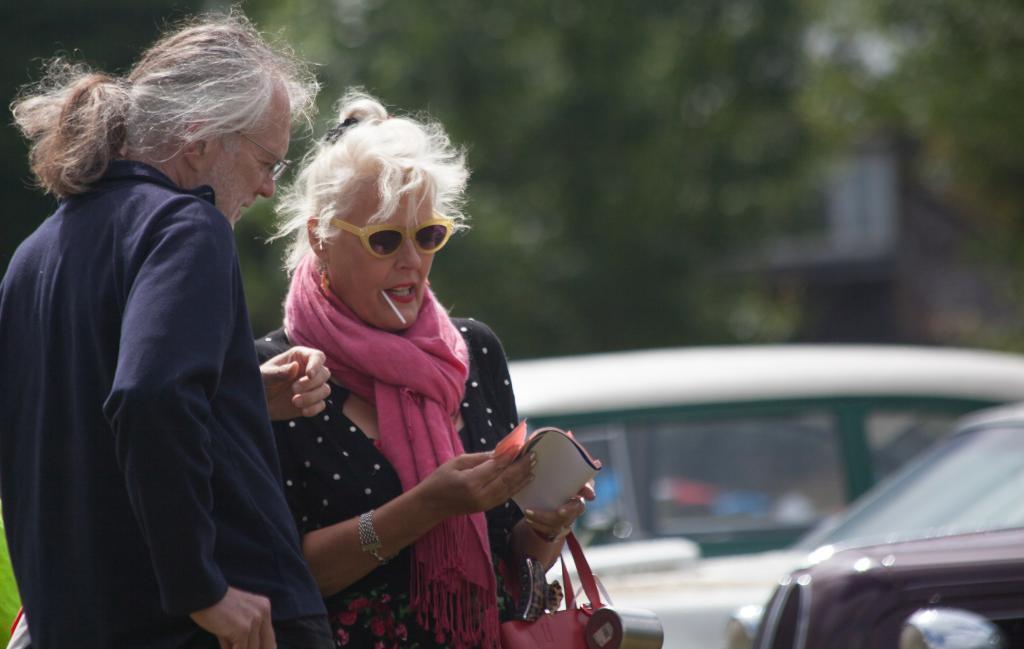In one or two sentences, can you explain what this image depicts? In the picture we can see a man and woman are standing and the woman is holding a cigarette in her mouth and the man is wearing a blue dress and beside them, we can see some cars are parked and in the background we can see some trees. 